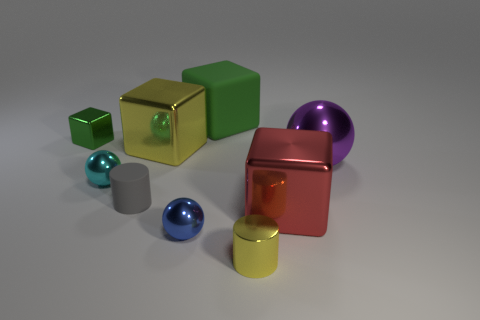There is a small metal object that is the same color as the matte cube; what is its shape?
Offer a very short reply. Cube. Is there a big red metallic object of the same shape as the gray rubber thing?
Your response must be concise. No. What number of tiny blue metallic spheres are there?
Provide a succinct answer. 1. The purple shiny thing has what shape?
Offer a very short reply. Sphere. How many red things are the same size as the yellow block?
Offer a very short reply. 1. Do the blue metallic object and the large purple metal object have the same shape?
Give a very brief answer. Yes. There is a large shiny thing that is in front of the tiny cylinder to the left of the yellow block; what color is it?
Your answer should be very brief. Red. How big is the ball that is both in front of the big purple thing and right of the cyan thing?
Make the answer very short. Small. Is there any other thing of the same color as the small metal cube?
Offer a very short reply. Yes. There is a small cyan thing that is made of the same material as the big red thing; what shape is it?
Your answer should be compact. Sphere. 